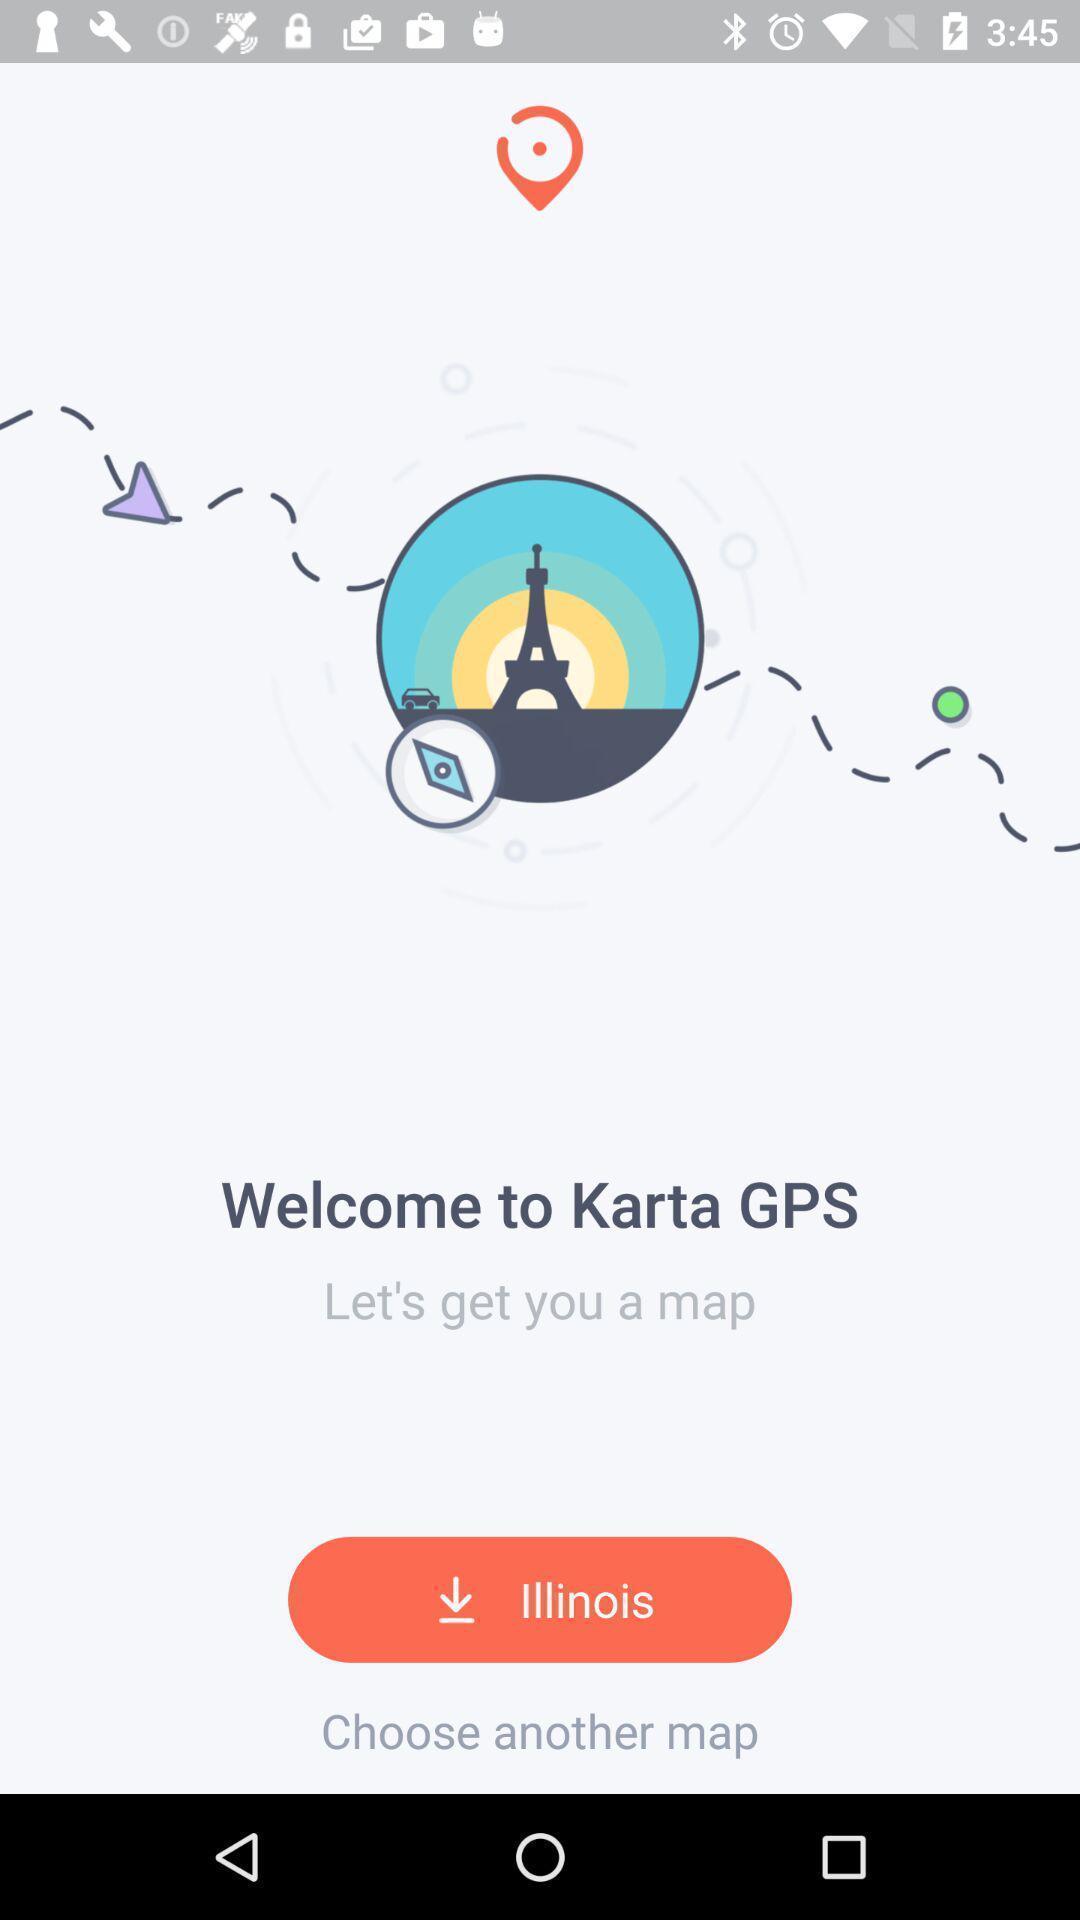Provide a detailed account of this screenshot. Welcome page. 